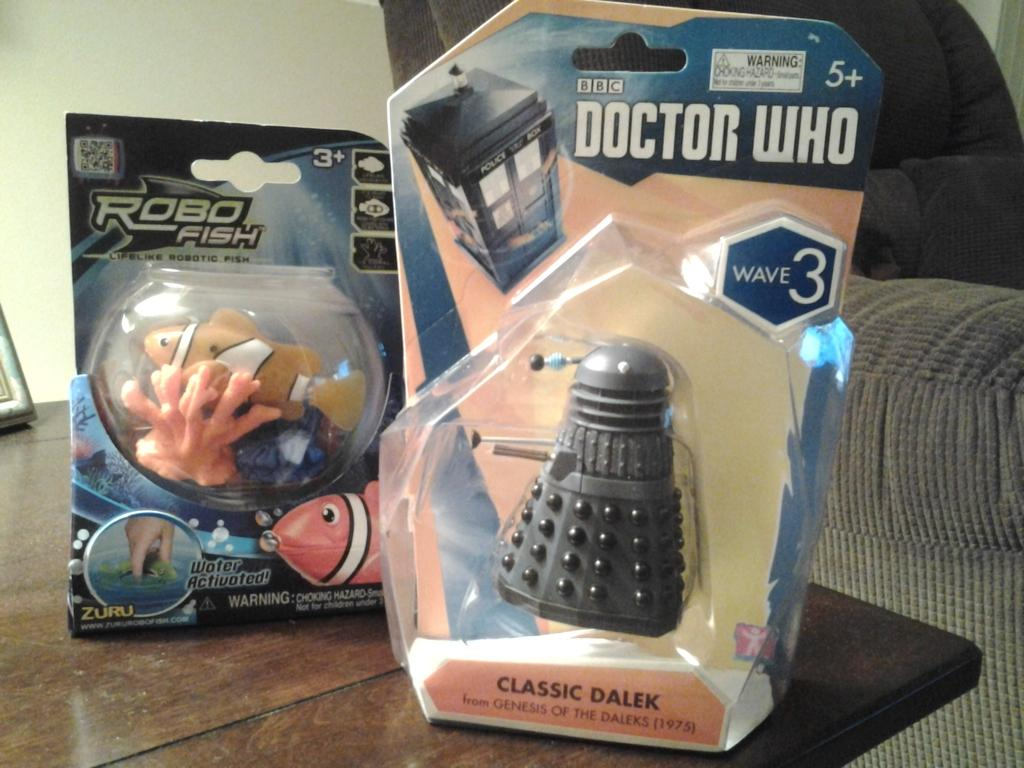What type of toys can be seen in the image? There are toy fishes in the image. Are there any other toys besides the toy fishes? Yes, there are other toys in the image. On what surface are the toys placed? The toys are placed on a wooden table. What can be seen on the right side of the image? There is a couch at the right side of the image. What is visible in the background of the image? There is a wall in the background of the image. What type of cord is connected to the toy fishes in the image? There is no cord connected to the toy fishes in the image. Can you tell me how many basketballs are visible in the image? There are no basketballs present in the image. 